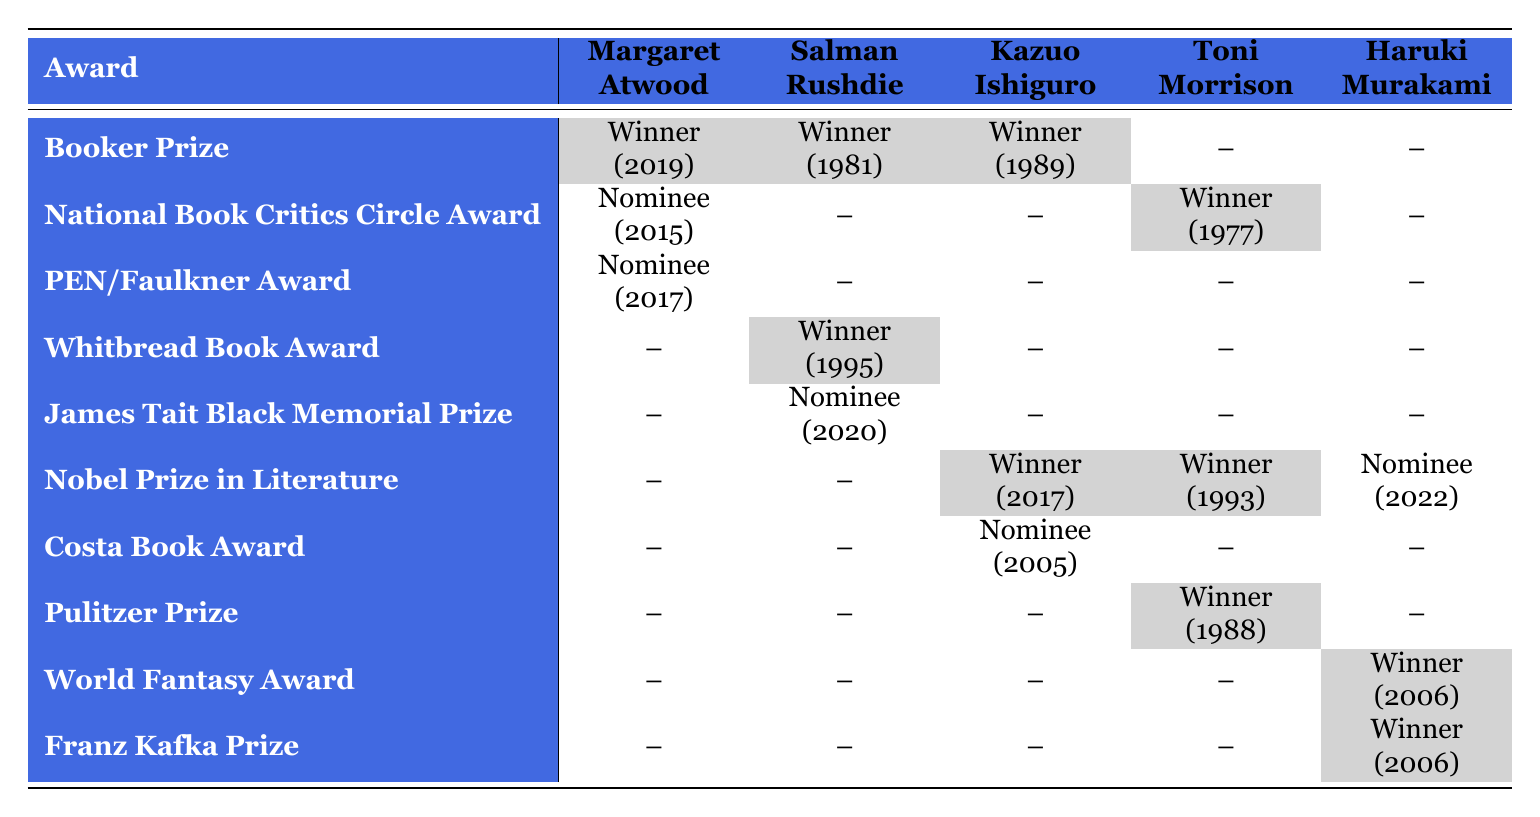What is the total number of awards won by Toni Morrison? In the table, Toni Morrison has three awards listed: Pulitzer Prize (Winner), Nobel Prize in Literature (Winner), and National Book Critics Circle Award (Winner). Each of these counts as one win, leading to a total of three awards won.
Answer: 3 Which author has the most nominations for awards? By reviewing the table, Salman Rushdie has two nominations (James Tait Black Memorial Prize and for Booker Prize) while others have either one nomination or none. Therefore, Salman Rushdie has the most nominations.
Answer: Salman Rushdie Did Haruki Murakami win the Nobel Prize in Literature? The table indicates that Haruki Murakami is marked as a nominee for the Nobel Prize in Literature, but there is no mention of him winning it; hence, the answer is no.
Answer: No How many unique awards have been won by Kazuo Ishiguro and Toni Morrison combined? Kazuo Ishiguro has won the Nobel Prize in Literature and the Booker Prize, totaling two unique awards. Toni Morrison has won the Pulitzer Prize, the Nobel Prize in Literature, and the National Book Critics Circle Award, totaling three unique awards. Adding these together gives a total of five unique awards.
Answer: 5 What percentage of Margaret Atwood's awards resulted in wins? Margaret Atwood has three awards, with one win (Booker Prize). The percentage is calculated by taking the number of wins (1) divided by the total number of awards (3), then multiplying by 100. Therefore, (1/3) * 100 equals approximately 33.33%.
Answer: 33.33% Which category has the most winners in the table? In the table, the Fiction category has multiple winners (Margaret Atwood, Salman Rushdie, Kazuo Ishiguro, and Toni Morrison). Comparatively, other categories like Literature and Novel have fewer winners. Hence, Fiction has the most winners.
Answer: Fiction Was Kazuo Ishiguro nominated for the Costa Book Award? The table shows that Kazuo Ishiguro was nominated for the Costa Book Award but did not win. Therefore, the answer is yes, but he was not awarded that particular honor.
Answer: Yes Among the authors, who is the only one with two wins from the same award? By analyzing the data, no author has two wins from the same award listed in the table. Each award is unique to the author; hence, there isn’t an author with two wins from the same award.
Answer: No 